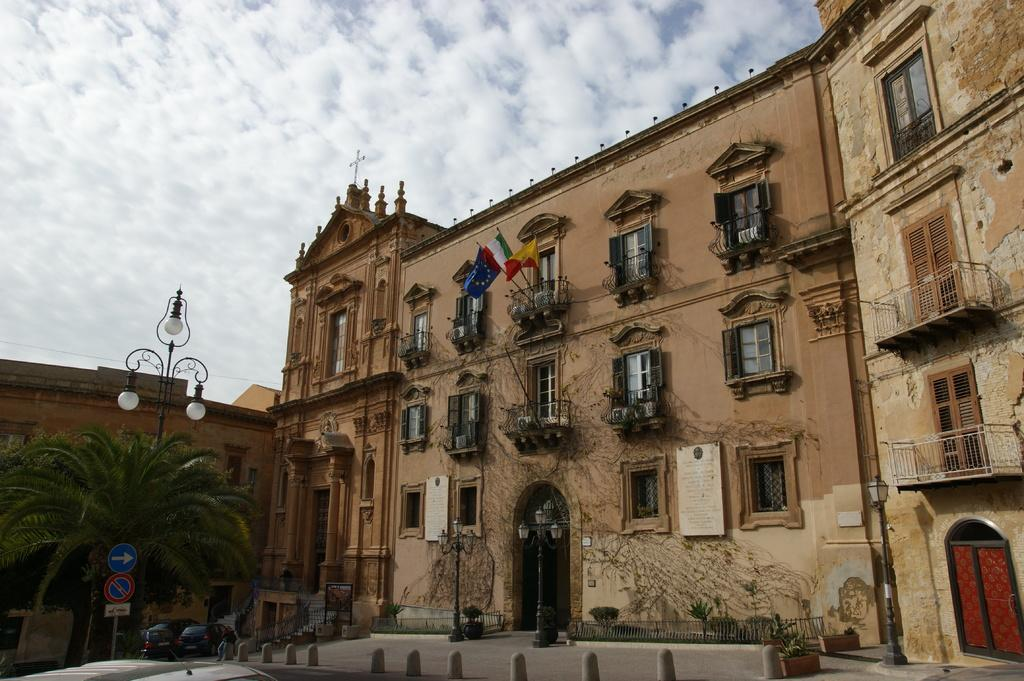What type of structures can be seen in the image? There are buildings in the image. What natural elements are present in the image? There are trees in the image. What are the light-poles used for in the image? The light-poles provide illumination in the image. What architectural feature can be seen in the image? There are glass windows in the image. What type of signage is present in the image? There are sign boards in the image. What is a feature that allows for vertical movement in the image? There are stairs in the image. What type of barrier is present in the image? There is fencing in the image. What type of transportation is visible in the image? There are vehicles on the road in the image. What is the color of the sky in the image? The sky is in white and blue color in the image. What type of pencil can be seen in the image? There is no pencil present in the image. How do the vehicles stop in the image? The vehicles do not stop in the image; they are in motion on the road. What time of day is depicted in the image? The time of day cannot be determined from the image, as there is no specific indication of morning or any other time. 